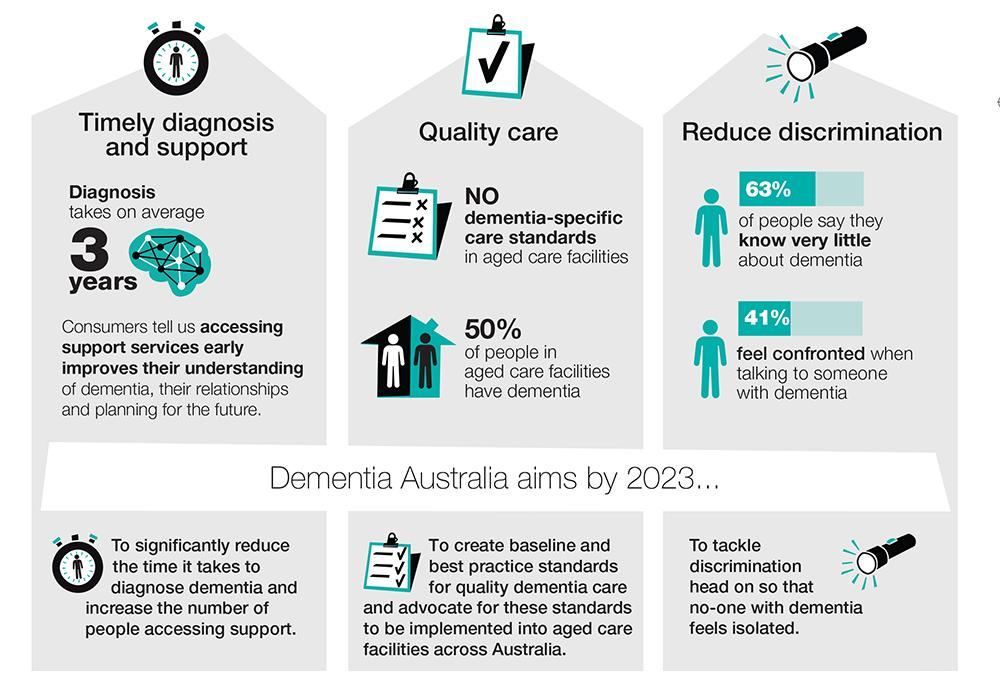Outline some significant characteristics in this image. According to recent studies, approximately 50% of people in age-care facilities in Australia have dementia. According to a recent survey in Australia, a significant majority of people, at 59%, do not feel confronted when talking to someone with dementia. According to a survey, 63% of people in Australia claim to have little to no knowledge about dementia. 